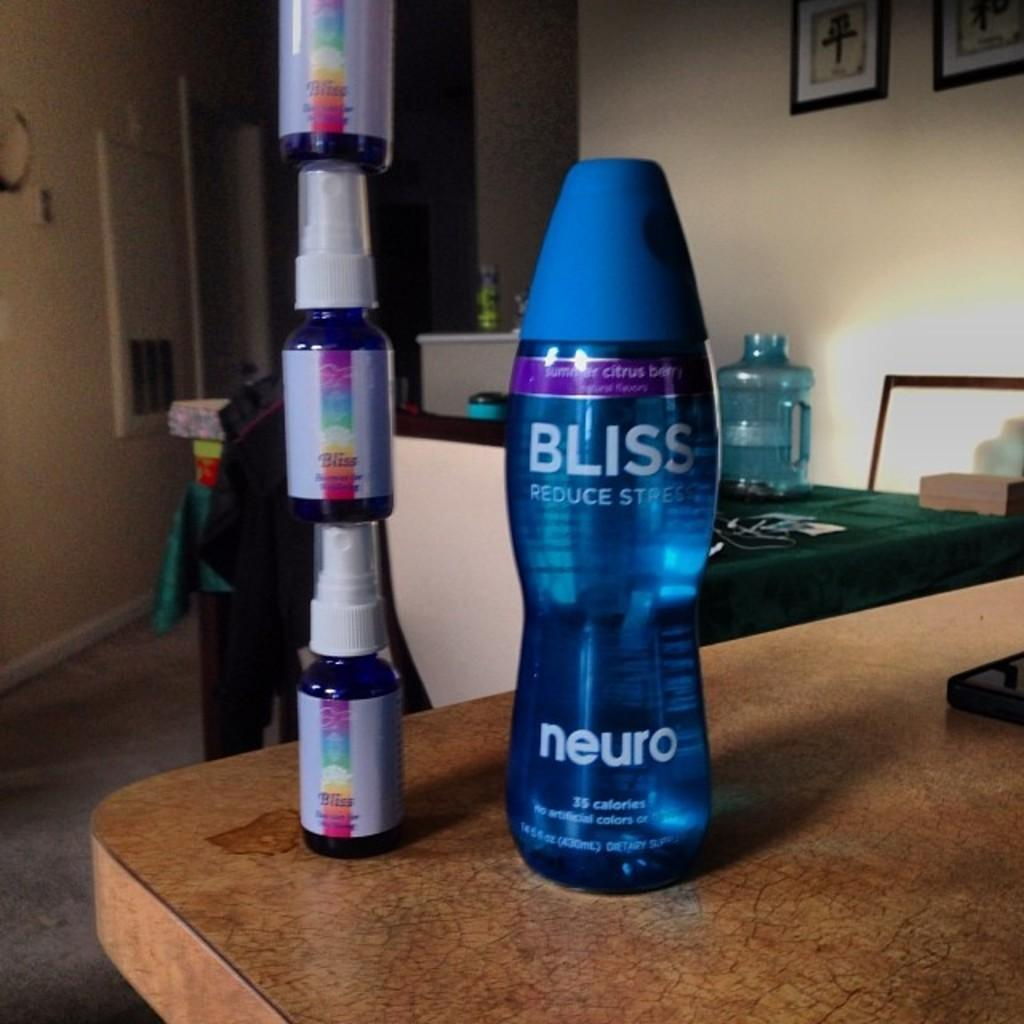What type of design element is present in the image? There is a border in the image. What can be seen on a table in the image? There are two objects on a table in the image. What is on the wall in the image? There are photos on a white wall in the image. What language is the spy using to communicate with the machine in the image? There is no spy or machine present in the image, so this question cannot be answered. 